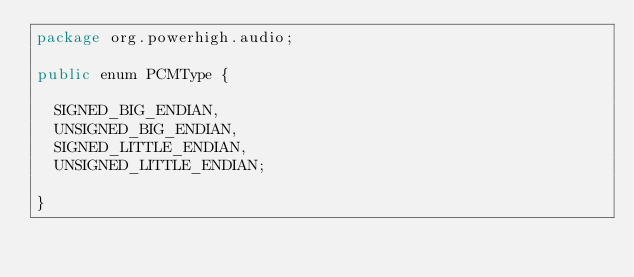Convert code to text. <code><loc_0><loc_0><loc_500><loc_500><_Java_>package org.powerhigh.audio;

public enum PCMType {

	SIGNED_BIG_ENDIAN,
	UNSIGNED_BIG_ENDIAN,
	SIGNED_LITTLE_ENDIAN,
	UNSIGNED_LITTLE_ENDIAN;
	
}
</code> 